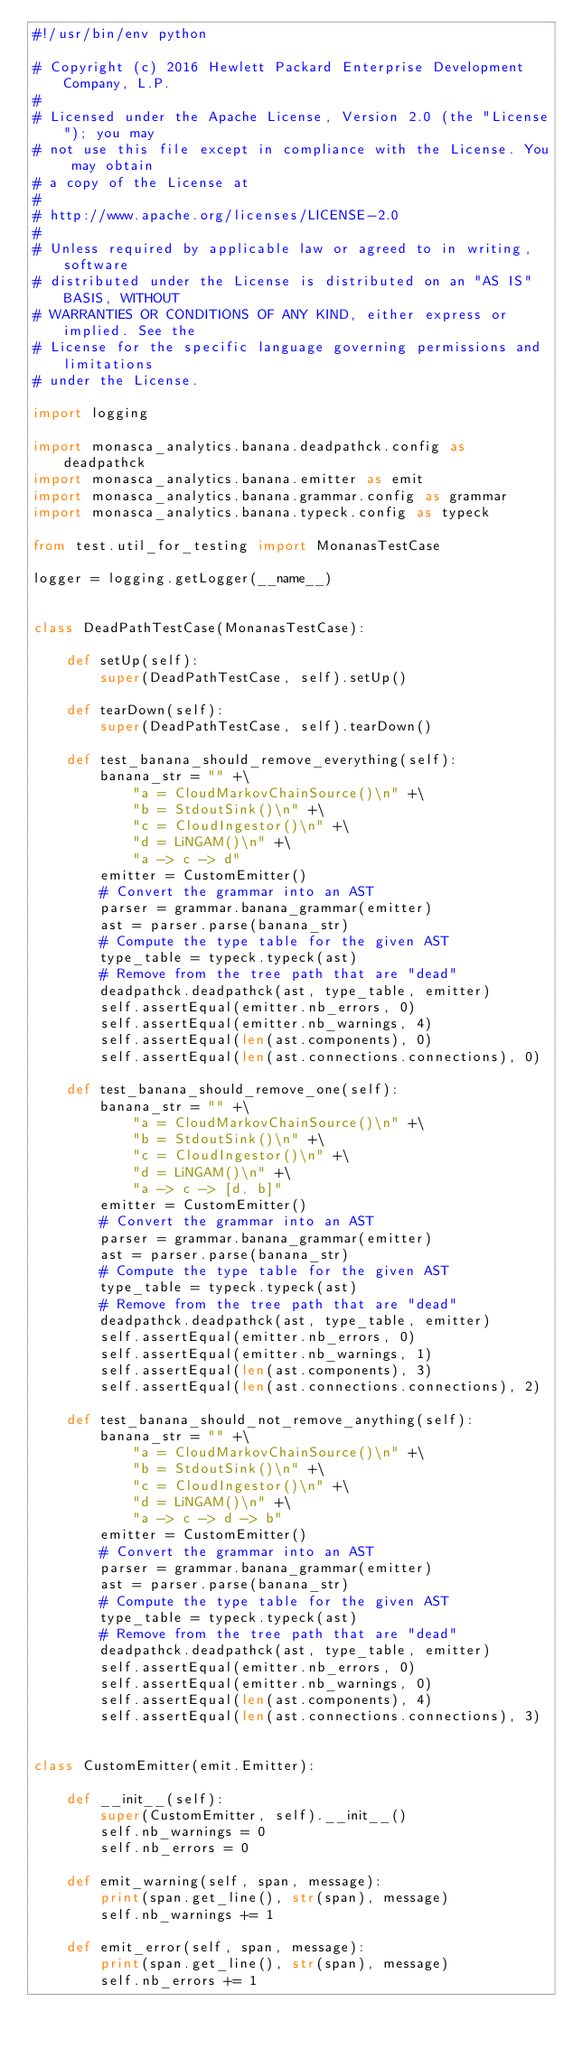Convert code to text. <code><loc_0><loc_0><loc_500><loc_500><_Python_>#!/usr/bin/env python

# Copyright (c) 2016 Hewlett Packard Enterprise Development Company, L.P.
#
# Licensed under the Apache License, Version 2.0 (the "License"); you may
# not use this file except in compliance with the License. You may obtain
# a copy of the License at
#
# http://www.apache.org/licenses/LICENSE-2.0
#
# Unless required by applicable law or agreed to in writing, software
# distributed under the License is distributed on an "AS IS" BASIS, WITHOUT
# WARRANTIES OR CONDITIONS OF ANY KIND, either express or implied. See the
# License for the specific language governing permissions and limitations
# under the License.

import logging

import monasca_analytics.banana.deadpathck.config as deadpathck
import monasca_analytics.banana.emitter as emit
import monasca_analytics.banana.grammar.config as grammar
import monasca_analytics.banana.typeck.config as typeck

from test.util_for_testing import MonanasTestCase

logger = logging.getLogger(__name__)


class DeadPathTestCase(MonanasTestCase):

    def setUp(self):
        super(DeadPathTestCase, self).setUp()

    def tearDown(self):
        super(DeadPathTestCase, self).tearDown()

    def test_banana_should_remove_everything(self):
        banana_str = "" +\
            "a = CloudMarkovChainSource()\n" +\
            "b = StdoutSink()\n" +\
            "c = CloudIngestor()\n" +\
            "d = LiNGAM()\n" +\
            "a -> c -> d"
        emitter = CustomEmitter()
        # Convert the grammar into an AST
        parser = grammar.banana_grammar(emitter)
        ast = parser.parse(banana_str)
        # Compute the type table for the given AST
        type_table = typeck.typeck(ast)
        # Remove from the tree path that are "dead"
        deadpathck.deadpathck(ast, type_table, emitter)
        self.assertEqual(emitter.nb_errors, 0)
        self.assertEqual(emitter.nb_warnings, 4)
        self.assertEqual(len(ast.components), 0)
        self.assertEqual(len(ast.connections.connections), 0)

    def test_banana_should_remove_one(self):
        banana_str = "" +\
            "a = CloudMarkovChainSource()\n" +\
            "b = StdoutSink()\n" +\
            "c = CloudIngestor()\n" +\
            "d = LiNGAM()\n" +\
            "a -> c -> [d, b]"
        emitter = CustomEmitter()
        # Convert the grammar into an AST
        parser = grammar.banana_grammar(emitter)
        ast = parser.parse(banana_str)
        # Compute the type table for the given AST
        type_table = typeck.typeck(ast)
        # Remove from the tree path that are "dead"
        deadpathck.deadpathck(ast, type_table, emitter)
        self.assertEqual(emitter.nb_errors, 0)
        self.assertEqual(emitter.nb_warnings, 1)
        self.assertEqual(len(ast.components), 3)
        self.assertEqual(len(ast.connections.connections), 2)

    def test_banana_should_not_remove_anything(self):
        banana_str = "" +\
            "a = CloudMarkovChainSource()\n" +\
            "b = StdoutSink()\n" +\
            "c = CloudIngestor()\n" +\
            "d = LiNGAM()\n" +\
            "a -> c -> d -> b"
        emitter = CustomEmitter()
        # Convert the grammar into an AST
        parser = grammar.banana_grammar(emitter)
        ast = parser.parse(banana_str)
        # Compute the type table for the given AST
        type_table = typeck.typeck(ast)
        # Remove from the tree path that are "dead"
        deadpathck.deadpathck(ast, type_table, emitter)
        self.assertEqual(emitter.nb_errors, 0)
        self.assertEqual(emitter.nb_warnings, 0)
        self.assertEqual(len(ast.components), 4)
        self.assertEqual(len(ast.connections.connections), 3)


class CustomEmitter(emit.Emitter):

    def __init__(self):
        super(CustomEmitter, self).__init__()
        self.nb_warnings = 0
        self.nb_errors = 0

    def emit_warning(self, span, message):
        print(span.get_line(), str(span), message)
        self.nb_warnings += 1

    def emit_error(self, span, message):
        print(span.get_line(), str(span), message)
        self.nb_errors += 1
</code> 